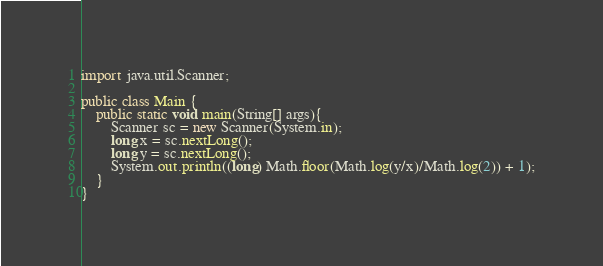Convert code to text. <code><loc_0><loc_0><loc_500><loc_500><_Java_>

import java.util.Scanner;

public class Main {
	public static void main(String[] args){
		Scanner sc = new Scanner(System.in);
		long x = sc.nextLong();
		long y = sc.nextLong();
		System.out.println((long) Math.floor(Math.log(y/x)/Math.log(2)) + 1);
	}
}
</code> 